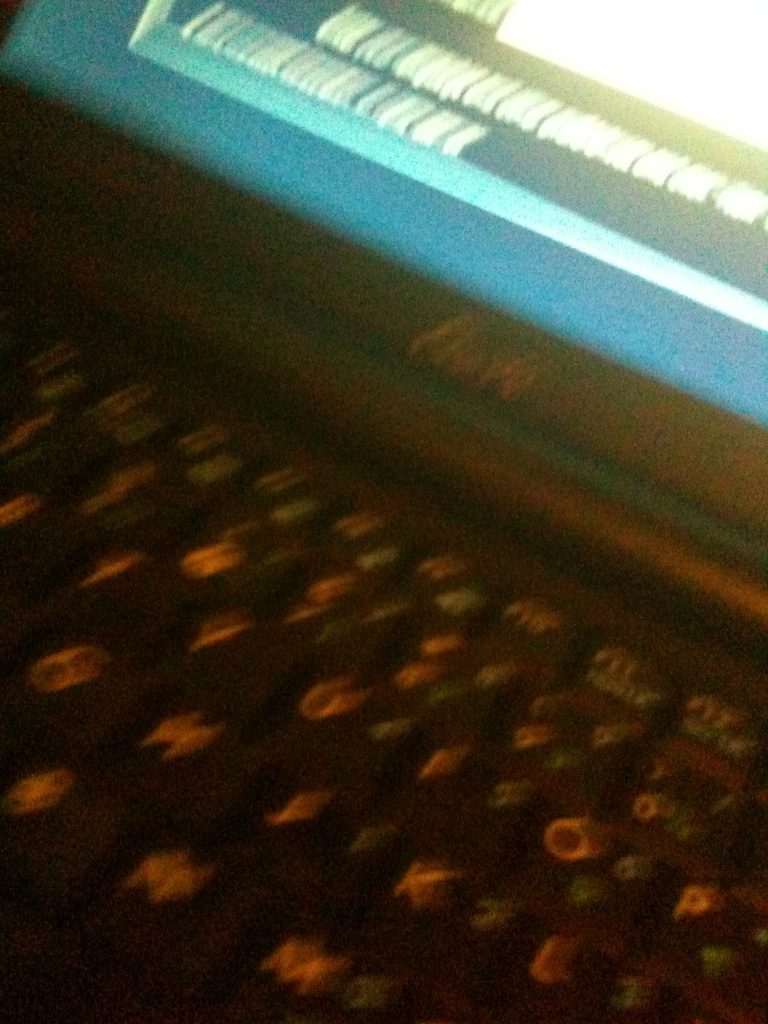What details can be noticed despite the poor quality of the image? The image seems to be blurry, but you can observe the basic layout of a computer keyboard. The keys appear slightly illuminated, suggesting either backlighting or reflection from a screen. Is there anything unusual about the keyboard that stands out? Due to the low resolution it is hard to discern finer details, but it seems like a standard layout. No particular anomalies or unique features stand out clearly. 